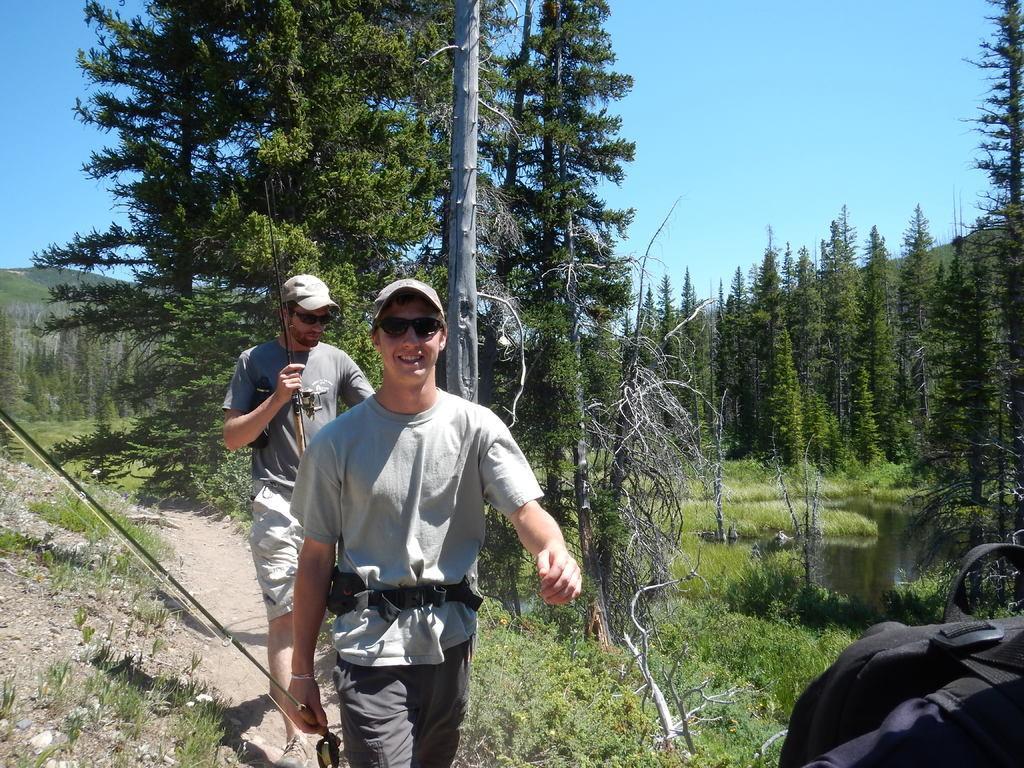How would you summarize this image in a sentence or two? In this image there are two people walking on a land, holding sticks in their hands in the background there are trees mountain and the sky. 